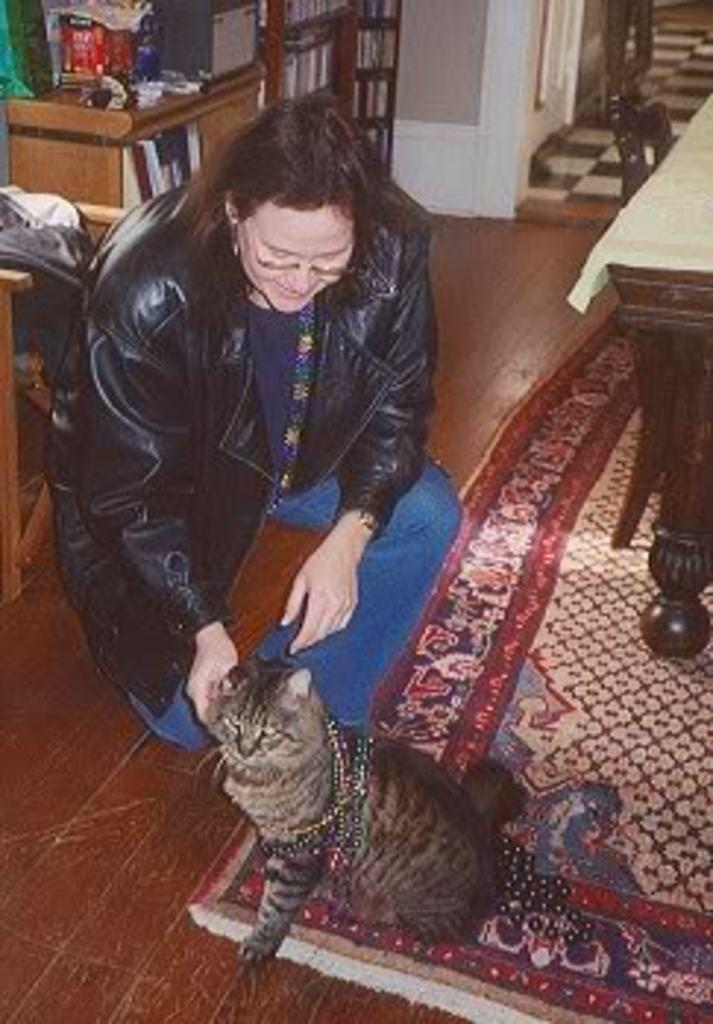Who is present in the image? There is a person in the image. What is the person doing in the image? The person is playing with a cat. What can be seen on the right side of the image? There is a table on the right side of the image. How is the table decorated or covered? The table is covered with a white cloth. What is located at the top of the image? There is a rack at the top of the image. What type of seed is being planted in the image? There is no seed or planting activity present in the image. How many family members are visible in the image? There is only one person visible in the image, so it cannot be considered a family scene. 